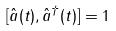Convert formula to latex. <formula><loc_0><loc_0><loc_500><loc_500>[ \hat { a } ( t ) , \hat { a } ^ { \dagger } ( t ) ] = 1</formula> 